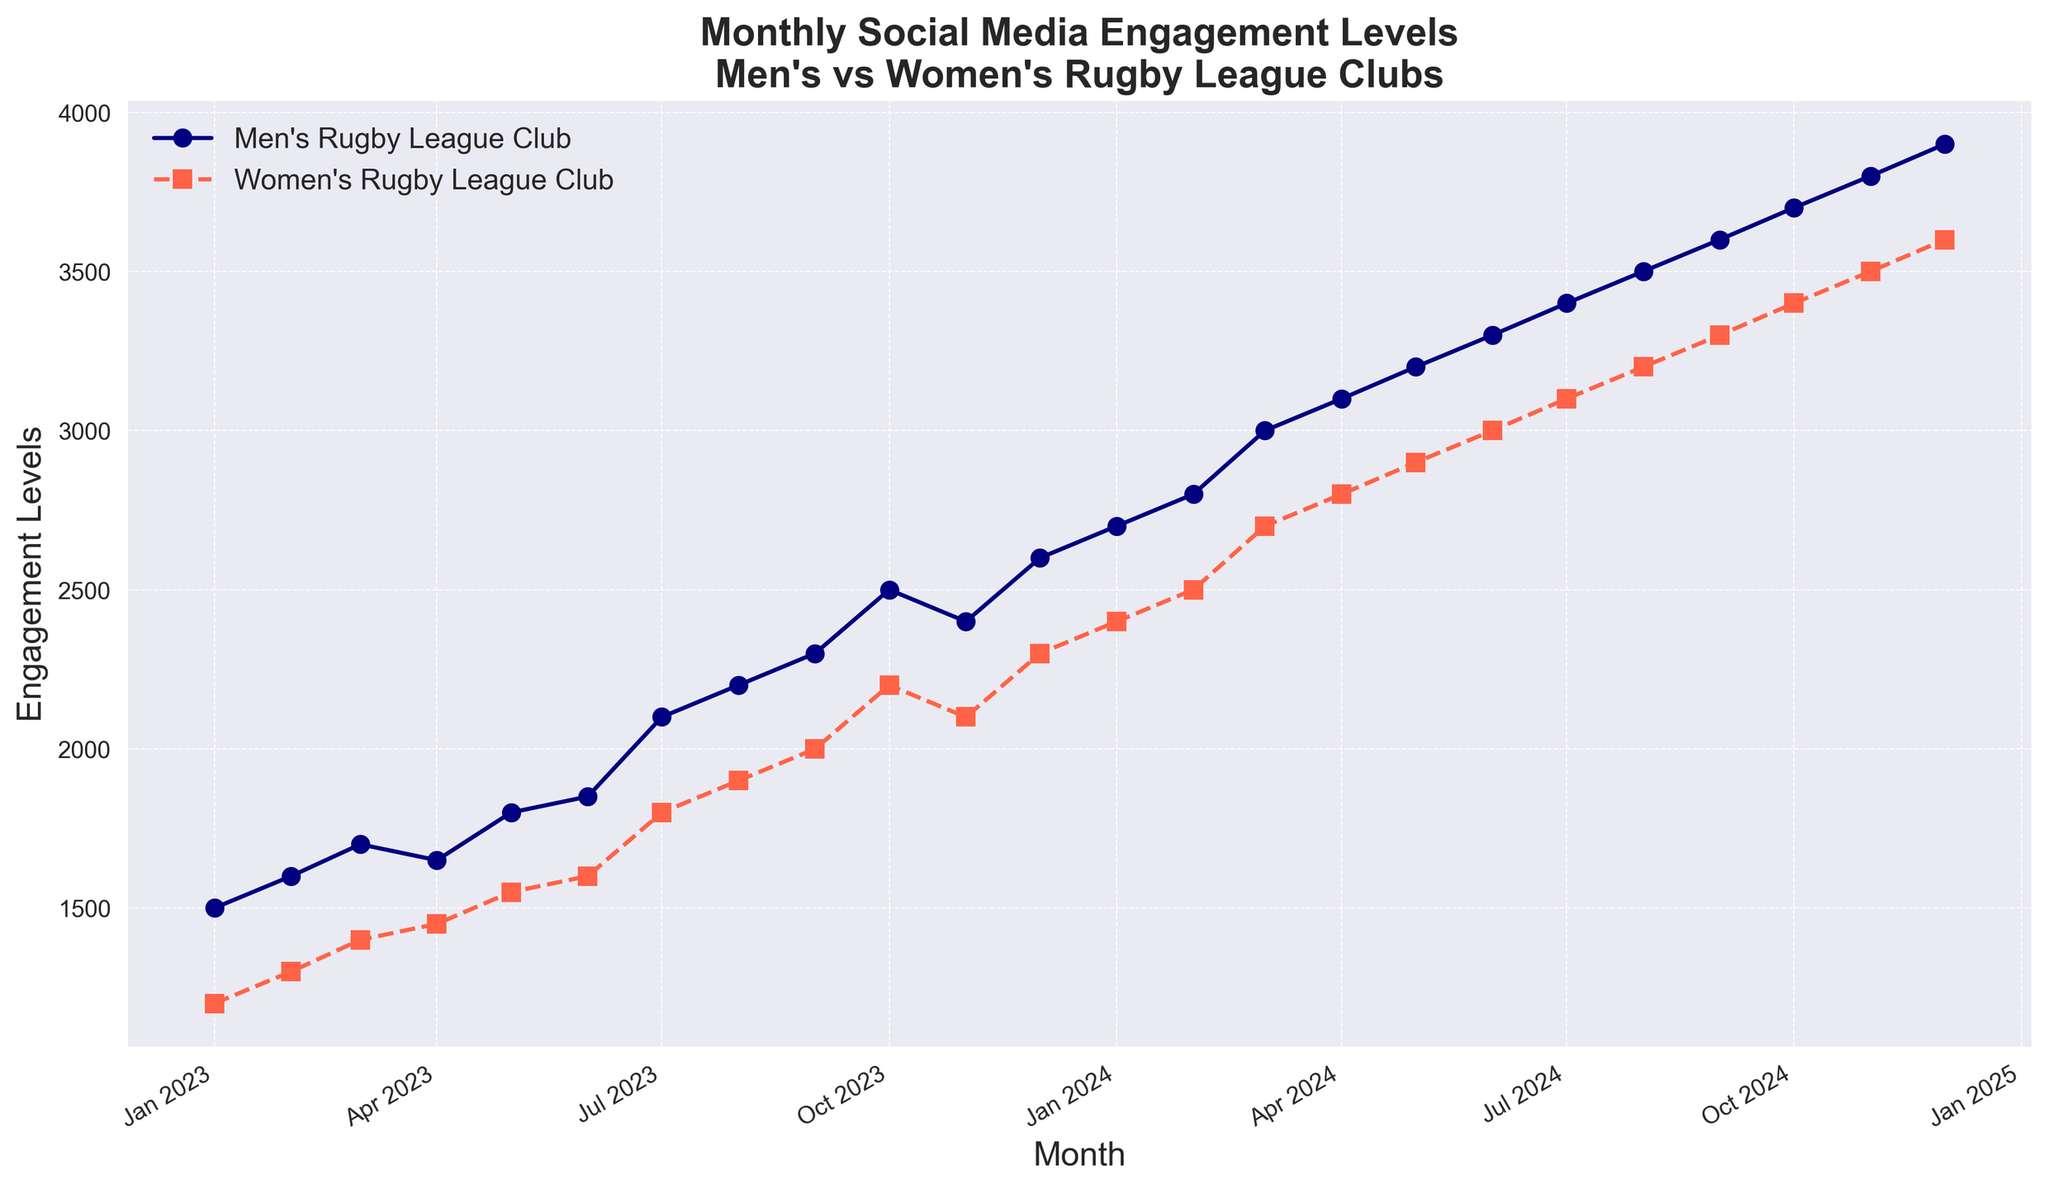Which month shows the highest engagement levels for men's rugby league clubs? By observing the Y-axis for the highest point on the men's rugby line, December 2024 has the highest engagement level for men's rugby league clubs.
Answer: December 2024 During which month did the women's rugby league club first surpass 2000 engagement levels? By tracking the women's rugby line, it first surpasses 2000 engagement levels in September 2023.
Answer: September 2023 In which month do men's rugby league clubs experience a decline in engagement, and what is the change? Observing the men's rugby line, the engagement levels decrease from October 2023 to November 2023. The change is from 2500 to 2400, a decline of 100.
Answer: October 2023 to November 2023, decrease of 100 Calculate the average engagement level for women's rugby league clubs over the last three months in 2024. Summing up the engagement levels for October, November, and December 2024: 3400, 3500, and 3600 respectively. Their total is 10500. Dividing this by 3 gives the average engagement level of 3500.
Answer: 3500 Compare the growth rate in engagement levels from January 2023 to December 2024 for both men's and women's rugby league clubs. For men's rugby, engagement grows from 1500 to 3900, a growth of 2400 in 24 months. For women's rugby, engagement grows from 1200 to 3600, a growth of 2400 in 24 months. Both have the same growth rate over 24 months.
Answer: Same What is the difference in engagement levels between men’s and women’s rugby league clubs in July 2024? In July 2024, men’s engagement is 3400 and women’s engagement is 3100. The difference is 3400 - 3100 = 300.
Answer: 300 Identify any month with the largest increase in engagement for women’s rugby league clubs and quantify it. The largest increase for women's rugby occurs from January 2024 to February 2024, where it jumps from 2400 to 2500. The increase is 2500 - 2400 = 100.
Answer: January 2024 to February 2024, increase of 100 What is the trend observed for men's rugby league clubs' engagement levels from January 2024 to December 2024? Observing the men’s rugby line from January 2024 to December 2024 shows a consistent upward trend with no declines. Engagement levels increase steadily each month.
Answer: Upward trend 